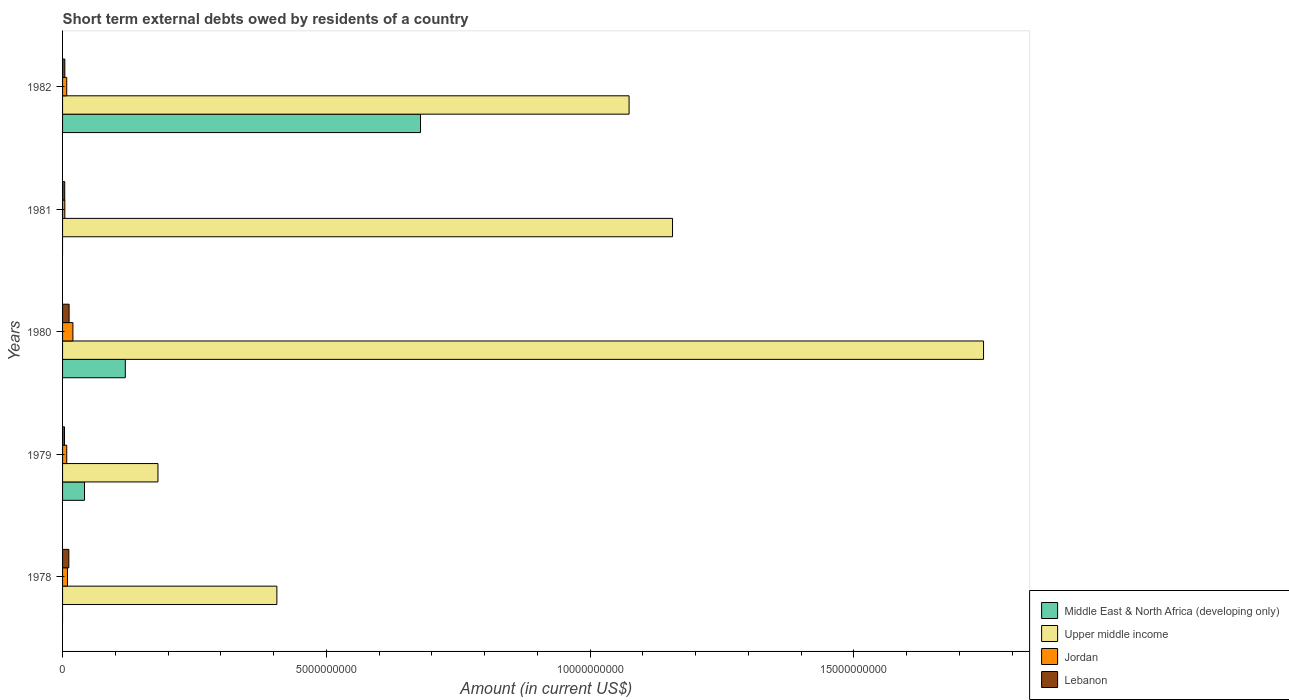How many different coloured bars are there?
Make the answer very short. 4. Are the number of bars per tick equal to the number of legend labels?
Your answer should be compact. No. How many bars are there on the 2nd tick from the top?
Ensure brevity in your answer.  3. What is the label of the 2nd group of bars from the top?
Provide a succinct answer. 1981. What is the amount of short-term external debts owed by residents in Middle East & North Africa (developing only) in 1982?
Offer a very short reply. 6.78e+09. Across all years, what is the maximum amount of short-term external debts owed by residents in Jordan?
Your answer should be very brief. 1.96e+08. Across all years, what is the minimum amount of short-term external debts owed by residents in Jordan?
Your answer should be compact. 4.30e+07. What is the total amount of short-term external debts owed by residents in Middle East & North Africa (developing only) in the graph?
Make the answer very short. 8.39e+09. What is the difference between the amount of short-term external debts owed by residents in Lebanon in 1978 and that in 1982?
Give a very brief answer. 7.60e+07. What is the difference between the amount of short-term external debts owed by residents in Lebanon in 1979 and the amount of short-term external debts owed by residents in Middle East & North Africa (developing only) in 1982?
Make the answer very short. -6.75e+09. What is the average amount of short-term external debts owed by residents in Middle East & North Africa (developing only) per year?
Offer a very short reply. 1.68e+09. In the year 1980, what is the difference between the amount of short-term external debts owed by residents in Jordan and amount of short-term external debts owed by residents in Lebanon?
Offer a very short reply. 7.20e+07. What is the ratio of the amount of short-term external debts owed by residents in Jordan in 1978 to that in 1979?
Your answer should be compact. 1.18. Is the amount of short-term external debts owed by residents in Jordan in 1979 less than that in 1982?
Offer a very short reply. No. Is the difference between the amount of short-term external debts owed by residents in Jordan in 1979 and 1980 greater than the difference between the amount of short-term external debts owed by residents in Lebanon in 1979 and 1980?
Ensure brevity in your answer.  No. What is the difference between the highest and the second highest amount of short-term external debts owed by residents in Upper middle income?
Give a very brief answer. 5.90e+09. What is the difference between the highest and the lowest amount of short-term external debts owed by residents in Jordan?
Your answer should be compact. 1.53e+08. Is it the case that in every year, the sum of the amount of short-term external debts owed by residents in Lebanon and amount of short-term external debts owed by residents in Middle East & North Africa (developing only) is greater than the sum of amount of short-term external debts owed by residents in Jordan and amount of short-term external debts owed by residents in Upper middle income?
Ensure brevity in your answer.  No. Is it the case that in every year, the sum of the amount of short-term external debts owed by residents in Upper middle income and amount of short-term external debts owed by residents in Jordan is greater than the amount of short-term external debts owed by residents in Middle East & North Africa (developing only)?
Give a very brief answer. Yes. What is the difference between two consecutive major ticks on the X-axis?
Your answer should be very brief. 5.00e+09. Are the values on the major ticks of X-axis written in scientific E-notation?
Make the answer very short. No. Where does the legend appear in the graph?
Keep it short and to the point. Bottom right. What is the title of the graph?
Your response must be concise. Short term external debts owed by residents of a country. What is the label or title of the Y-axis?
Keep it short and to the point. Years. What is the Amount (in current US$) in Upper middle income in 1978?
Offer a terse response. 4.06e+09. What is the Amount (in current US$) in Jordan in 1978?
Provide a short and direct response. 9.30e+07. What is the Amount (in current US$) of Lebanon in 1978?
Your answer should be compact. 1.19e+08. What is the Amount (in current US$) of Middle East & North Africa (developing only) in 1979?
Keep it short and to the point. 4.16e+08. What is the Amount (in current US$) in Upper middle income in 1979?
Give a very brief answer. 1.81e+09. What is the Amount (in current US$) in Jordan in 1979?
Your response must be concise. 7.90e+07. What is the Amount (in current US$) of Lebanon in 1979?
Your answer should be compact. 3.70e+07. What is the Amount (in current US$) of Middle East & North Africa (developing only) in 1980?
Your answer should be very brief. 1.19e+09. What is the Amount (in current US$) in Upper middle income in 1980?
Your response must be concise. 1.75e+1. What is the Amount (in current US$) of Jordan in 1980?
Offer a very short reply. 1.96e+08. What is the Amount (in current US$) in Lebanon in 1980?
Offer a very short reply. 1.24e+08. What is the Amount (in current US$) in Upper middle income in 1981?
Make the answer very short. 1.16e+1. What is the Amount (in current US$) of Jordan in 1981?
Offer a very short reply. 4.30e+07. What is the Amount (in current US$) of Lebanon in 1981?
Provide a succinct answer. 4.10e+07. What is the Amount (in current US$) in Middle East & North Africa (developing only) in 1982?
Give a very brief answer. 6.78e+09. What is the Amount (in current US$) in Upper middle income in 1982?
Offer a terse response. 1.07e+1. What is the Amount (in current US$) in Jordan in 1982?
Offer a very short reply. 7.90e+07. What is the Amount (in current US$) in Lebanon in 1982?
Provide a short and direct response. 4.30e+07. Across all years, what is the maximum Amount (in current US$) of Middle East & North Africa (developing only)?
Your answer should be compact. 6.78e+09. Across all years, what is the maximum Amount (in current US$) in Upper middle income?
Offer a very short reply. 1.75e+1. Across all years, what is the maximum Amount (in current US$) of Jordan?
Offer a very short reply. 1.96e+08. Across all years, what is the maximum Amount (in current US$) in Lebanon?
Ensure brevity in your answer.  1.24e+08. Across all years, what is the minimum Amount (in current US$) in Upper middle income?
Provide a short and direct response. 1.81e+09. Across all years, what is the minimum Amount (in current US$) of Jordan?
Provide a short and direct response. 4.30e+07. Across all years, what is the minimum Amount (in current US$) of Lebanon?
Keep it short and to the point. 3.70e+07. What is the total Amount (in current US$) of Middle East & North Africa (developing only) in the graph?
Provide a succinct answer. 8.39e+09. What is the total Amount (in current US$) of Upper middle income in the graph?
Keep it short and to the point. 4.56e+1. What is the total Amount (in current US$) in Jordan in the graph?
Provide a short and direct response. 4.90e+08. What is the total Amount (in current US$) of Lebanon in the graph?
Ensure brevity in your answer.  3.64e+08. What is the difference between the Amount (in current US$) in Upper middle income in 1978 and that in 1979?
Provide a short and direct response. 2.25e+09. What is the difference between the Amount (in current US$) of Jordan in 1978 and that in 1979?
Your response must be concise. 1.40e+07. What is the difference between the Amount (in current US$) in Lebanon in 1978 and that in 1979?
Keep it short and to the point. 8.20e+07. What is the difference between the Amount (in current US$) in Upper middle income in 1978 and that in 1980?
Your response must be concise. -1.34e+1. What is the difference between the Amount (in current US$) in Jordan in 1978 and that in 1980?
Make the answer very short. -1.03e+08. What is the difference between the Amount (in current US$) in Lebanon in 1978 and that in 1980?
Offer a terse response. -5.00e+06. What is the difference between the Amount (in current US$) of Upper middle income in 1978 and that in 1981?
Make the answer very short. -7.50e+09. What is the difference between the Amount (in current US$) in Lebanon in 1978 and that in 1981?
Make the answer very short. 7.80e+07. What is the difference between the Amount (in current US$) in Upper middle income in 1978 and that in 1982?
Your answer should be very brief. -6.68e+09. What is the difference between the Amount (in current US$) of Jordan in 1978 and that in 1982?
Ensure brevity in your answer.  1.40e+07. What is the difference between the Amount (in current US$) of Lebanon in 1978 and that in 1982?
Your answer should be compact. 7.60e+07. What is the difference between the Amount (in current US$) in Middle East & North Africa (developing only) in 1979 and that in 1980?
Offer a very short reply. -7.73e+08. What is the difference between the Amount (in current US$) in Upper middle income in 1979 and that in 1980?
Your answer should be very brief. -1.56e+1. What is the difference between the Amount (in current US$) in Jordan in 1979 and that in 1980?
Your answer should be very brief. -1.17e+08. What is the difference between the Amount (in current US$) in Lebanon in 1979 and that in 1980?
Provide a succinct answer. -8.70e+07. What is the difference between the Amount (in current US$) of Upper middle income in 1979 and that in 1981?
Provide a succinct answer. -9.75e+09. What is the difference between the Amount (in current US$) of Jordan in 1979 and that in 1981?
Give a very brief answer. 3.60e+07. What is the difference between the Amount (in current US$) in Middle East & North Africa (developing only) in 1979 and that in 1982?
Provide a succinct answer. -6.37e+09. What is the difference between the Amount (in current US$) in Upper middle income in 1979 and that in 1982?
Your answer should be very brief. -8.93e+09. What is the difference between the Amount (in current US$) in Jordan in 1979 and that in 1982?
Your answer should be very brief. 0. What is the difference between the Amount (in current US$) in Lebanon in 1979 and that in 1982?
Offer a terse response. -6.00e+06. What is the difference between the Amount (in current US$) of Upper middle income in 1980 and that in 1981?
Offer a very short reply. 5.90e+09. What is the difference between the Amount (in current US$) in Jordan in 1980 and that in 1981?
Your response must be concise. 1.53e+08. What is the difference between the Amount (in current US$) in Lebanon in 1980 and that in 1981?
Provide a short and direct response. 8.30e+07. What is the difference between the Amount (in current US$) in Middle East & North Africa (developing only) in 1980 and that in 1982?
Make the answer very short. -5.60e+09. What is the difference between the Amount (in current US$) in Upper middle income in 1980 and that in 1982?
Give a very brief answer. 6.72e+09. What is the difference between the Amount (in current US$) in Jordan in 1980 and that in 1982?
Provide a succinct answer. 1.17e+08. What is the difference between the Amount (in current US$) in Lebanon in 1980 and that in 1982?
Ensure brevity in your answer.  8.10e+07. What is the difference between the Amount (in current US$) of Upper middle income in 1981 and that in 1982?
Your response must be concise. 8.23e+08. What is the difference between the Amount (in current US$) of Jordan in 1981 and that in 1982?
Keep it short and to the point. -3.60e+07. What is the difference between the Amount (in current US$) in Lebanon in 1981 and that in 1982?
Your answer should be compact. -2.00e+06. What is the difference between the Amount (in current US$) in Upper middle income in 1978 and the Amount (in current US$) in Jordan in 1979?
Keep it short and to the point. 3.98e+09. What is the difference between the Amount (in current US$) in Upper middle income in 1978 and the Amount (in current US$) in Lebanon in 1979?
Offer a very short reply. 4.03e+09. What is the difference between the Amount (in current US$) in Jordan in 1978 and the Amount (in current US$) in Lebanon in 1979?
Provide a succinct answer. 5.60e+07. What is the difference between the Amount (in current US$) in Upper middle income in 1978 and the Amount (in current US$) in Jordan in 1980?
Make the answer very short. 3.87e+09. What is the difference between the Amount (in current US$) of Upper middle income in 1978 and the Amount (in current US$) of Lebanon in 1980?
Your response must be concise. 3.94e+09. What is the difference between the Amount (in current US$) of Jordan in 1978 and the Amount (in current US$) of Lebanon in 1980?
Offer a terse response. -3.10e+07. What is the difference between the Amount (in current US$) of Upper middle income in 1978 and the Amount (in current US$) of Jordan in 1981?
Give a very brief answer. 4.02e+09. What is the difference between the Amount (in current US$) of Upper middle income in 1978 and the Amount (in current US$) of Lebanon in 1981?
Provide a short and direct response. 4.02e+09. What is the difference between the Amount (in current US$) in Jordan in 1978 and the Amount (in current US$) in Lebanon in 1981?
Keep it short and to the point. 5.20e+07. What is the difference between the Amount (in current US$) in Upper middle income in 1978 and the Amount (in current US$) in Jordan in 1982?
Your response must be concise. 3.98e+09. What is the difference between the Amount (in current US$) of Upper middle income in 1978 and the Amount (in current US$) of Lebanon in 1982?
Your answer should be compact. 4.02e+09. What is the difference between the Amount (in current US$) of Middle East & North Africa (developing only) in 1979 and the Amount (in current US$) of Upper middle income in 1980?
Offer a very short reply. -1.70e+1. What is the difference between the Amount (in current US$) in Middle East & North Africa (developing only) in 1979 and the Amount (in current US$) in Jordan in 1980?
Provide a succinct answer. 2.20e+08. What is the difference between the Amount (in current US$) of Middle East & North Africa (developing only) in 1979 and the Amount (in current US$) of Lebanon in 1980?
Your answer should be very brief. 2.92e+08. What is the difference between the Amount (in current US$) in Upper middle income in 1979 and the Amount (in current US$) in Jordan in 1980?
Your answer should be compact. 1.61e+09. What is the difference between the Amount (in current US$) of Upper middle income in 1979 and the Amount (in current US$) of Lebanon in 1980?
Provide a short and direct response. 1.68e+09. What is the difference between the Amount (in current US$) in Jordan in 1979 and the Amount (in current US$) in Lebanon in 1980?
Make the answer very short. -4.50e+07. What is the difference between the Amount (in current US$) in Middle East & North Africa (developing only) in 1979 and the Amount (in current US$) in Upper middle income in 1981?
Offer a very short reply. -1.11e+1. What is the difference between the Amount (in current US$) in Middle East & North Africa (developing only) in 1979 and the Amount (in current US$) in Jordan in 1981?
Give a very brief answer. 3.73e+08. What is the difference between the Amount (in current US$) in Middle East & North Africa (developing only) in 1979 and the Amount (in current US$) in Lebanon in 1981?
Give a very brief answer. 3.75e+08. What is the difference between the Amount (in current US$) of Upper middle income in 1979 and the Amount (in current US$) of Jordan in 1981?
Your answer should be compact. 1.77e+09. What is the difference between the Amount (in current US$) in Upper middle income in 1979 and the Amount (in current US$) in Lebanon in 1981?
Your answer should be compact. 1.77e+09. What is the difference between the Amount (in current US$) in Jordan in 1979 and the Amount (in current US$) in Lebanon in 1981?
Offer a terse response. 3.80e+07. What is the difference between the Amount (in current US$) in Middle East & North Africa (developing only) in 1979 and the Amount (in current US$) in Upper middle income in 1982?
Offer a terse response. -1.03e+1. What is the difference between the Amount (in current US$) in Middle East & North Africa (developing only) in 1979 and the Amount (in current US$) in Jordan in 1982?
Your answer should be compact. 3.37e+08. What is the difference between the Amount (in current US$) of Middle East & North Africa (developing only) in 1979 and the Amount (in current US$) of Lebanon in 1982?
Provide a short and direct response. 3.73e+08. What is the difference between the Amount (in current US$) in Upper middle income in 1979 and the Amount (in current US$) in Jordan in 1982?
Provide a succinct answer. 1.73e+09. What is the difference between the Amount (in current US$) of Upper middle income in 1979 and the Amount (in current US$) of Lebanon in 1982?
Make the answer very short. 1.77e+09. What is the difference between the Amount (in current US$) of Jordan in 1979 and the Amount (in current US$) of Lebanon in 1982?
Your answer should be compact. 3.60e+07. What is the difference between the Amount (in current US$) in Middle East & North Africa (developing only) in 1980 and the Amount (in current US$) in Upper middle income in 1981?
Provide a succinct answer. -1.04e+1. What is the difference between the Amount (in current US$) of Middle East & North Africa (developing only) in 1980 and the Amount (in current US$) of Jordan in 1981?
Provide a short and direct response. 1.15e+09. What is the difference between the Amount (in current US$) in Middle East & North Africa (developing only) in 1980 and the Amount (in current US$) in Lebanon in 1981?
Offer a terse response. 1.15e+09. What is the difference between the Amount (in current US$) of Upper middle income in 1980 and the Amount (in current US$) of Jordan in 1981?
Ensure brevity in your answer.  1.74e+1. What is the difference between the Amount (in current US$) of Upper middle income in 1980 and the Amount (in current US$) of Lebanon in 1981?
Provide a short and direct response. 1.74e+1. What is the difference between the Amount (in current US$) in Jordan in 1980 and the Amount (in current US$) in Lebanon in 1981?
Offer a very short reply. 1.55e+08. What is the difference between the Amount (in current US$) of Middle East & North Africa (developing only) in 1980 and the Amount (in current US$) of Upper middle income in 1982?
Offer a very short reply. -9.55e+09. What is the difference between the Amount (in current US$) of Middle East & North Africa (developing only) in 1980 and the Amount (in current US$) of Jordan in 1982?
Keep it short and to the point. 1.11e+09. What is the difference between the Amount (in current US$) of Middle East & North Africa (developing only) in 1980 and the Amount (in current US$) of Lebanon in 1982?
Provide a short and direct response. 1.15e+09. What is the difference between the Amount (in current US$) in Upper middle income in 1980 and the Amount (in current US$) in Jordan in 1982?
Ensure brevity in your answer.  1.74e+1. What is the difference between the Amount (in current US$) of Upper middle income in 1980 and the Amount (in current US$) of Lebanon in 1982?
Give a very brief answer. 1.74e+1. What is the difference between the Amount (in current US$) in Jordan in 1980 and the Amount (in current US$) in Lebanon in 1982?
Your answer should be compact. 1.53e+08. What is the difference between the Amount (in current US$) in Upper middle income in 1981 and the Amount (in current US$) in Jordan in 1982?
Your answer should be very brief. 1.15e+1. What is the difference between the Amount (in current US$) of Upper middle income in 1981 and the Amount (in current US$) of Lebanon in 1982?
Provide a short and direct response. 1.15e+1. What is the average Amount (in current US$) in Middle East & North Africa (developing only) per year?
Offer a terse response. 1.68e+09. What is the average Amount (in current US$) in Upper middle income per year?
Offer a terse response. 9.13e+09. What is the average Amount (in current US$) of Jordan per year?
Your answer should be compact. 9.80e+07. What is the average Amount (in current US$) of Lebanon per year?
Give a very brief answer. 7.28e+07. In the year 1978, what is the difference between the Amount (in current US$) of Upper middle income and Amount (in current US$) of Jordan?
Make the answer very short. 3.97e+09. In the year 1978, what is the difference between the Amount (in current US$) of Upper middle income and Amount (in current US$) of Lebanon?
Ensure brevity in your answer.  3.94e+09. In the year 1978, what is the difference between the Amount (in current US$) of Jordan and Amount (in current US$) of Lebanon?
Provide a short and direct response. -2.60e+07. In the year 1979, what is the difference between the Amount (in current US$) in Middle East & North Africa (developing only) and Amount (in current US$) in Upper middle income?
Keep it short and to the point. -1.39e+09. In the year 1979, what is the difference between the Amount (in current US$) of Middle East & North Africa (developing only) and Amount (in current US$) of Jordan?
Give a very brief answer. 3.37e+08. In the year 1979, what is the difference between the Amount (in current US$) of Middle East & North Africa (developing only) and Amount (in current US$) of Lebanon?
Keep it short and to the point. 3.79e+08. In the year 1979, what is the difference between the Amount (in current US$) of Upper middle income and Amount (in current US$) of Jordan?
Your answer should be compact. 1.73e+09. In the year 1979, what is the difference between the Amount (in current US$) in Upper middle income and Amount (in current US$) in Lebanon?
Ensure brevity in your answer.  1.77e+09. In the year 1979, what is the difference between the Amount (in current US$) in Jordan and Amount (in current US$) in Lebanon?
Offer a very short reply. 4.20e+07. In the year 1980, what is the difference between the Amount (in current US$) of Middle East & North Africa (developing only) and Amount (in current US$) of Upper middle income?
Your answer should be very brief. -1.63e+1. In the year 1980, what is the difference between the Amount (in current US$) in Middle East & North Africa (developing only) and Amount (in current US$) in Jordan?
Offer a very short reply. 9.93e+08. In the year 1980, what is the difference between the Amount (in current US$) of Middle East & North Africa (developing only) and Amount (in current US$) of Lebanon?
Provide a succinct answer. 1.07e+09. In the year 1980, what is the difference between the Amount (in current US$) of Upper middle income and Amount (in current US$) of Jordan?
Give a very brief answer. 1.73e+1. In the year 1980, what is the difference between the Amount (in current US$) in Upper middle income and Amount (in current US$) in Lebanon?
Keep it short and to the point. 1.73e+1. In the year 1980, what is the difference between the Amount (in current US$) in Jordan and Amount (in current US$) in Lebanon?
Your response must be concise. 7.20e+07. In the year 1981, what is the difference between the Amount (in current US$) in Upper middle income and Amount (in current US$) in Jordan?
Your response must be concise. 1.15e+1. In the year 1981, what is the difference between the Amount (in current US$) in Upper middle income and Amount (in current US$) in Lebanon?
Offer a terse response. 1.15e+1. In the year 1981, what is the difference between the Amount (in current US$) in Jordan and Amount (in current US$) in Lebanon?
Keep it short and to the point. 2.00e+06. In the year 1982, what is the difference between the Amount (in current US$) in Middle East & North Africa (developing only) and Amount (in current US$) in Upper middle income?
Provide a succinct answer. -3.95e+09. In the year 1982, what is the difference between the Amount (in current US$) of Middle East & North Africa (developing only) and Amount (in current US$) of Jordan?
Your answer should be very brief. 6.71e+09. In the year 1982, what is the difference between the Amount (in current US$) of Middle East & North Africa (developing only) and Amount (in current US$) of Lebanon?
Keep it short and to the point. 6.74e+09. In the year 1982, what is the difference between the Amount (in current US$) of Upper middle income and Amount (in current US$) of Jordan?
Your answer should be very brief. 1.07e+1. In the year 1982, what is the difference between the Amount (in current US$) of Upper middle income and Amount (in current US$) of Lebanon?
Provide a succinct answer. 1.07e+1. In the year 1982, what is the difference between the Amount (in current US$) of Jordan and Amount (in current US$) of Lebanon?
Your response must be concise. 3.60e+07. What is the ratio of the Amount (in current US$) in Upper middle income in 1978 to that in 1979?
Ensure brevity in your answer.  2.25. What is the ratio of the Amount (in current US$) of Jordan in 1978 to that in 1979?
Make the answer very short. 1.18. What is the ratio of the Amount (in current US$) in Lebanon in 1978 to that in 1979?
Keep it short and to the point. 3.22. What is the ratio of the Amount (in current US$) in Upper middle income in 1978 to that in 1980?
Your answer should be very brief. 0.23. What is the ratio of the Amount (in current US$) of Jordan in 1978 to that in 1980?
Your response must be concise. 0.47. What is the ratio of the Amount (in current US$) in Lebanon in 1978 to that in 1980?
Make the answer very short. 0.96. What is the ratio of the Amount (in current US$) of Upper middle income in 1978 to that in 1981?
Give a very brief answer. 0.35. What is the ratio of the Amount (in current US$) of Jordan in 1978 to that in 1981?
Offer a terse response. 2.16. What is the ratio of the Amount (in current US$) in Lebanon in 1978 to that in 1981?
Your response must be concise. 2.9. What is the ratio of the Amount (in current US$) of Upper middle income in 1978 to that in 1982?
Provide a short and direct response. 0.38. What is the ratio of the Amount (in current US$) in Jordan in 1978 to that in 1982?
Your response must be concise. 1.18. What is the ratio of the Amount (in current US$) in Lebanon in 1978 to that in 1982?
Your answer should be very brief. 2.77. What is the ratio of the Amount (in current US$) of Middle East & North Africa (developing only) in 1979 to that in 1980?
Provide a short and direct response. 0.35. What is the ratio of the Amount (in current US$) of Upper middle income in 1979 to that in 1980?
Provide a short and direct response. 0.1. What is the ratio of the Amount (in current US$) of Jordan in 1979 to that in 1980?
Offer a terse response. 0.4. What is the ratio of the Amount (in current US$) of Lebanon in 1979 to that in 1980?
Your answer should be compact. 0.3. What is the ratio of the Amount (in current US$) of Upper middle income in 1979 to that in 1981?
Give a very brief answer. 0.16. What is the ratio of the Amount (in current US$) in Jordan in 1979 to that in 1981?
Keep it short and to the point. 1.84. What is the ratio of the Amount (in current US$) of Lebanon in 1979 to that in 1981?
Give a very brief answer. 0.9. What is the ratio of the Amount (in current US$) in Middle East & North Africa (developing only) in 1979 to that in 1982?
Your answer should be very brief. 0.06. What is the ratio of the Amount (in current US$) in Upper middle income in 1979 to that in 1982?
Your answer should be very brief. 0.17. What is the ratio of the Amount (in current US$) in Jordan in 1979 to that in 1982?
Your answer should be very brief. 1. What is the ratio of the Amount (in current US$) of Lebanon in 1979 to that in 1982?
Give a very brief answer. 0.86. What is the ratio of the Amount (in current US$) of Upper middle income in 1980 to that in 1981?
Your answer should be very brief. 1.51. What is the ratio of the Amount (in current US$) in Jordan in 1980 to that in 1981?
Your answer should be compact. 4.56. What is the ratio of the Amount (in current US$) of Lebanon in 1980 to that in 1981?
Provide a succinct answer. 3.02. What is the ratio of the Amount (in current US$) of Middle East & North Africa (developing only) in 1980 to that in 1982?
Give a very brief answer. 0.18. What is the ratio of the Amount (in current US$) of Upper middle income in 1980 to that in 1982?
Ensure brevity in your answer.  1.63. What is the ratio of the Amount (in current US$) of Jordan in 1980 to that in 1982?
Provide a short and direct response. 2.48. What is the ratio of the Amount (in current US$) in Lebanon in 1980 to that in 1982?
Keep it short and to the point. 2.88. What is the ratio of the Amount (in current US$) of Upper middle income in 1981 to that in 1982?
Provide a short and direct response. 1.08. What is the ratio of the Amount (in current US$) in Jordan in 1981 to that in 1982?
Offer a very short reply. 0.54. What is the ratio of the Amount (in current US$) of Lebanon in 1981 to that in 1982?
Ensure brevity in your answer.  0.95. What is the difference between the highest and the second highest Amount (in current US$) in Middle East & North Africa (developing only)?
Offer a terse response. 5.60e+09. What is the difference between the highest and the second highest Amount (in current US$) of Upper middle income?
Offer a very short reply. 5.90e+09. What is the difference between the highest and the second highest Amount (in current US$) in Jordan?
Make the answer very short. 1.03e+08. What is the difference between the highest and the lowest Amount (in current US$) of Middle East & North Africa (developing only)?
Your answer should be compact. 6.78e+09. What is the difference between the highest and the lowest Amount (in current US$) in Upper middle income?
Keep it short and to the point. 1.56e+1. What is the difference between the highest and the lowest Amount (in current US$) of Jordan?
Offer a very short reply. 1.53e+08. What is the difference between the highest and the lowest Amount (in current US$) of Lebanon?
Provide a short and direct response. 8.70e+07. 